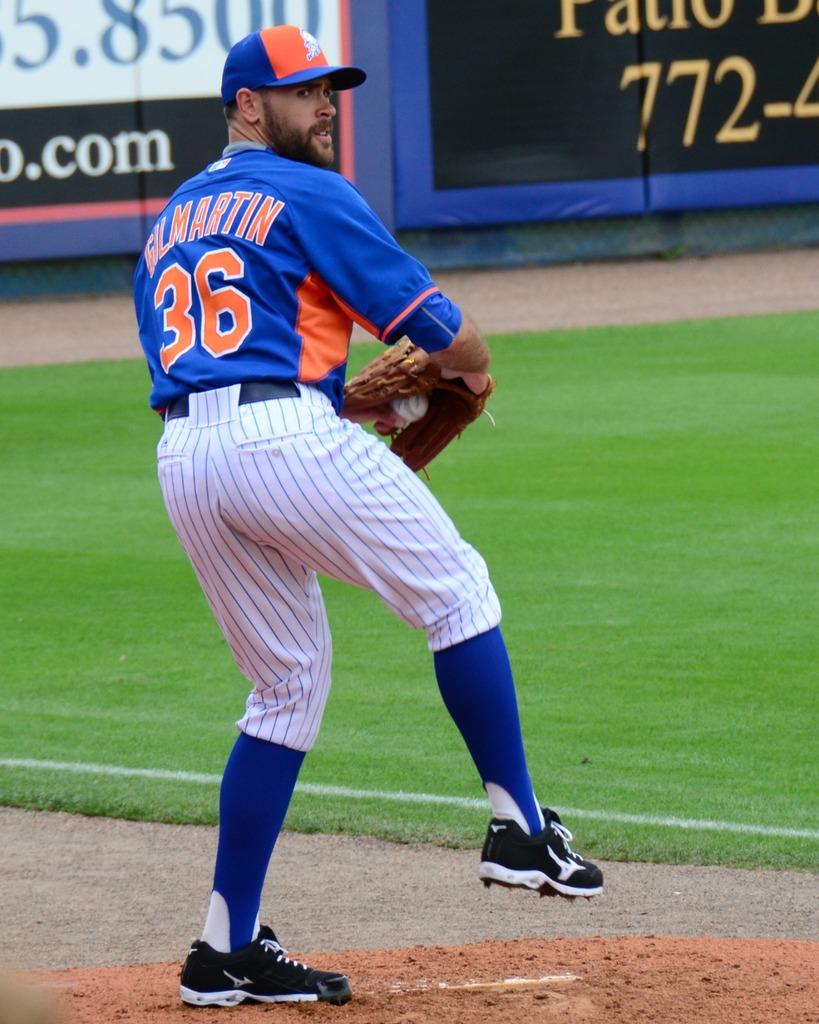What player number is getting ready to throw a ball?
Make the answer very short. 36. What are the first three digits of the phone number in the back?
Make the answer very short. 772. 